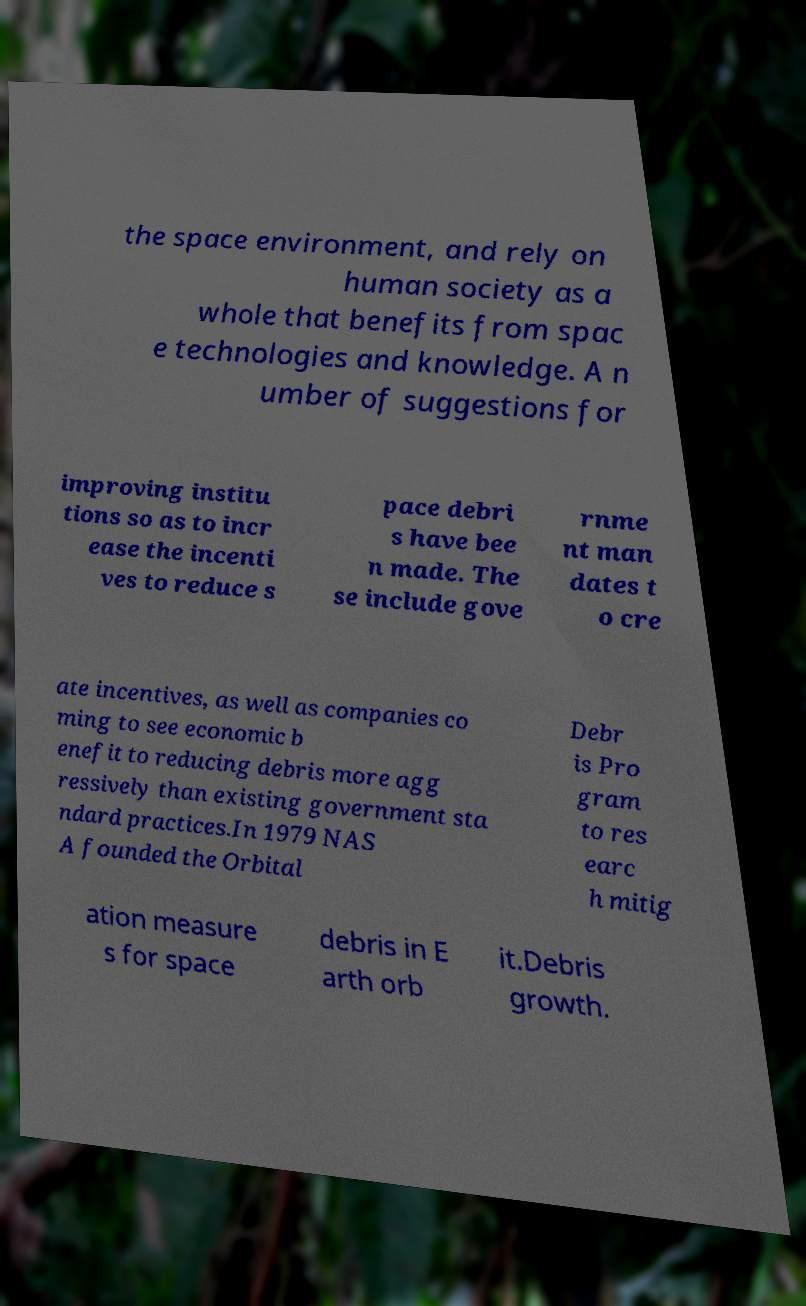Could you assist in decoding the text presented in this image and type it out clearly? the space environment, and rely on human society as a whole that benefits from spac e technologies and knowledge. A n umber of suggestions for improving institu tions so as to incr ease the incenti ves to reduce s pace debri s have bee n made. The se include gove rnme nt man dates t o cre ate incentives, as well as companies co ming to see economic b enefit to reducing debris more agg ressively than existing government sta ndard practices.In 1979 NAS A founded the Orbital Debr is Pro gram to res earc h mitig ation measure s for space debris in E arth orb it.Debris growth. 